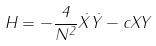<formula> <loc_0><loc_0><loc_500><loc_500>H = - \frac { 4 } { N ^ { 2 } } \dot { X } \dot { Y } - c X Y</formula> 